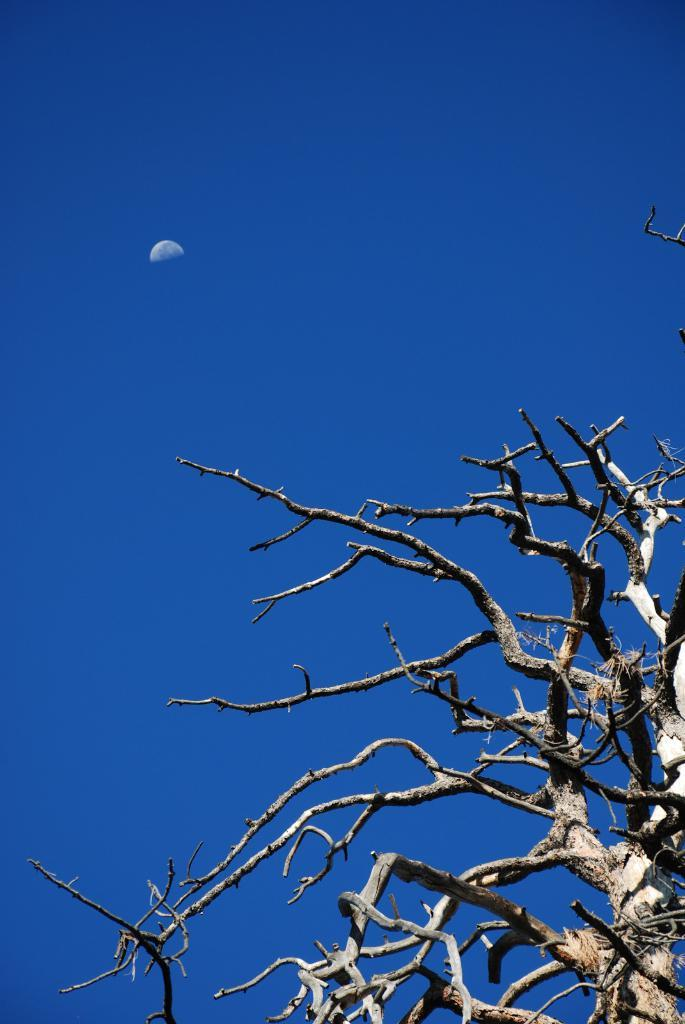What type of tree is at the bottom of the image? There is a bare tree at the bottom of the image. What can be seen in the sky in the background of the image? There is a moon visible in the sky in the background of the image. What country is the squirrel from in the image? There is no squirrel present in the image. How does the moon control the tides in the image? The image does not depict any tides or their control by the moon. 